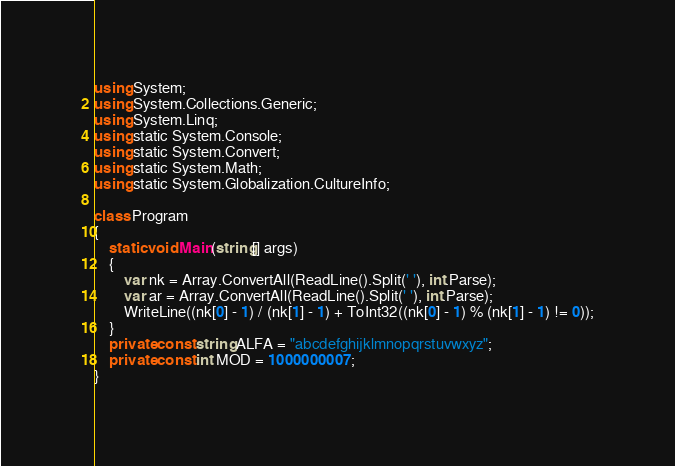Convert code to text. <code><loc_0><loc_0><loc_500><loc_500><_C#_>using System;
using System.Collections.Generic;
using System.Linq;
using static System.Console;
using static System.Convert;
using static System.Math;
using static System.Globalization.CultureInfo;
 
class Program
{
    static void Main(string[] args)
    {
        var nk = Array.ConvertAll(ReadLine().Split(' '), int.Parse);
        var ar = Array.ConvertAll(ReadLine().Split(' '), int.Parse);
        WriteLine((nk[0] - 1) / (nk[1] - 1) + ToInt32((nk[0] - 1) % (nk[1] - 1) != 0));
    }
    private const string ALFA = "abcdefghijklmnopqrstuvwxyz";
    private const int MOD = 1000000007;
}</code> 